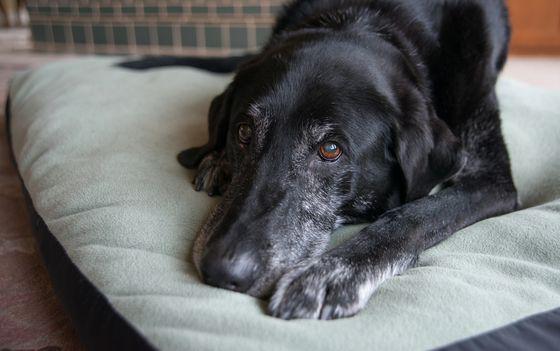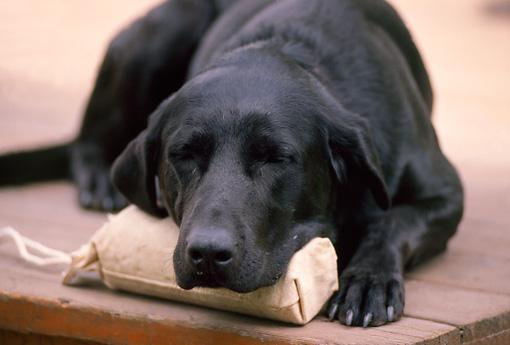The first image is the image on the left, the second image is the image on the right. For the images displayed, is the sentence "Each image shows one sleeping dog, and each dog is sleeping with its head facing the camera and rightside-up." factually correct? Answer yes or no. Yes. The first image is the image on the left, the second image is the image on the right. For the images displayed, is the sentence "A single dog is sleeping in each of the pictures." factually correct? Answer yes or no. No. 